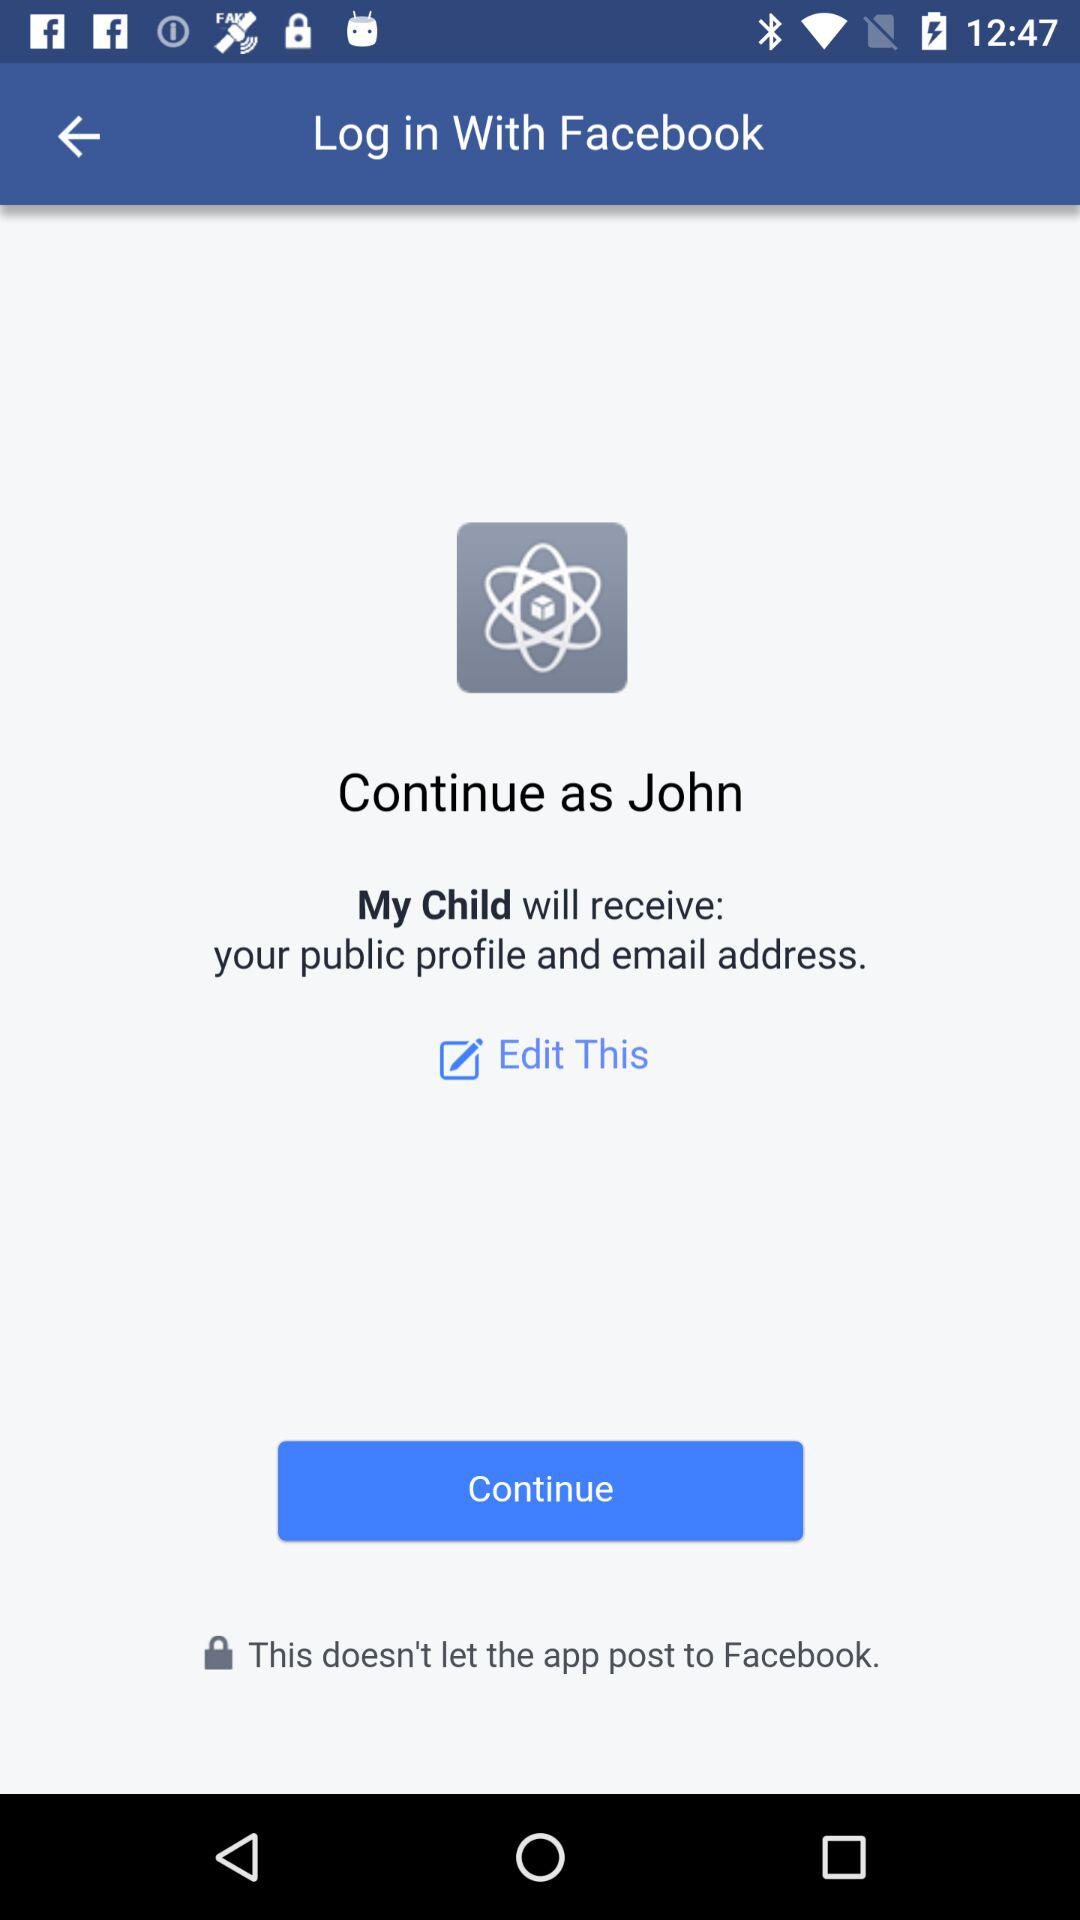Who will receive the public profile and email address? The application "My Child" will receive the public profile and email address. 